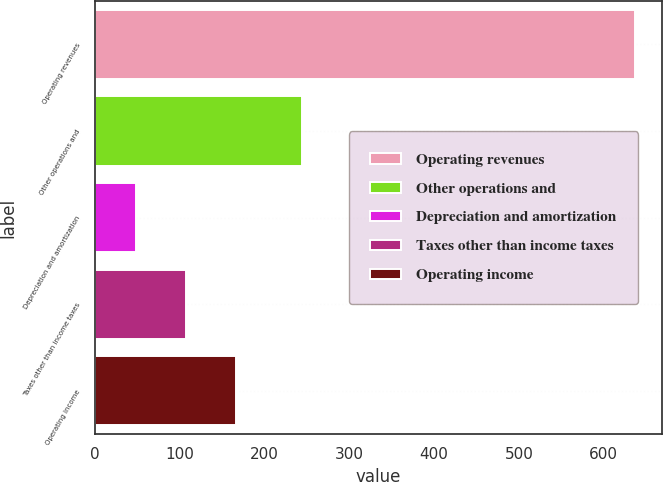Convert chart. <chart><loc_0><loc_0><loc_500><loc_500><bar_chart><fcel>Operating revenues<fcel>Other operations and<fcel>Depreciation and amortization<fcel>Taxes other than income taxes<fcel>Operating income<nl><fcel>637<fcel>244<fcel>49<fcel>107.8<fcel>166.6<nl></chart> 